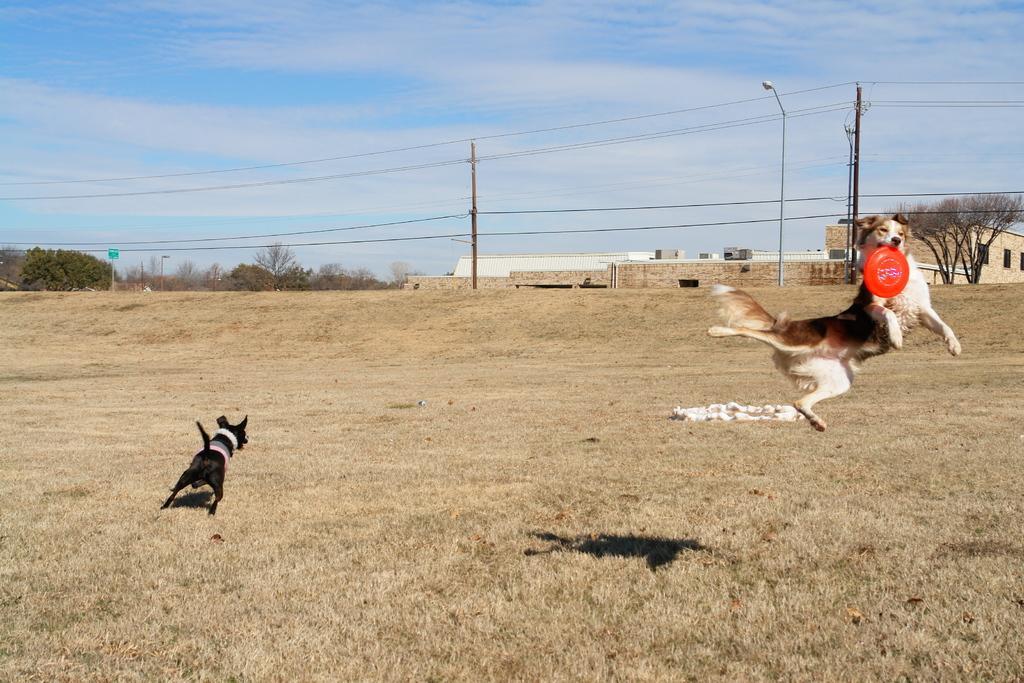Describe this image in one or two sentences. In this picture there is a dog holding the object and jumping and there is a black dog running. At the back there are buildings and trees and there are poles and there are wires on the poles. At the top there is sky and there are clouds. At the bottom there is grass and there might be cloth on the grass. 